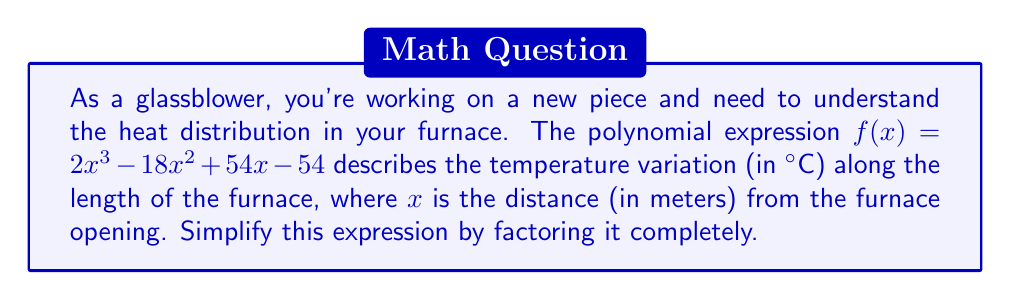Provide a solution to this math problem. Let's approach this step-by-step:

1) First, we can factor out the greatest common factor (GCF):
   $f(x) = 2x^3 - 18x^2 + 54x - 54$
   $f(x) = 2(x^3 - 9x^2 + 27x - 27)$

2) Now, let's focus on the expression inside the parentheses:
   $x^3 - 9x^2 + 27x - 27$

3) This looks like it might be a perfect cube. The general form of a perfect cube is:
   $(a - b)^3 = a^3 - 3a^2b + 3ab^2 - b^3$

4) In our case, if we compare terms:
   $a^3 = x^3$, so $a = x$
   $-b^3 = -27$, so $b = 3$

5) Let's verify if the middle terms match:
   $-3a^2b = -3x^2(3) = -9x^2$ (matches)
   $3ab^2 = 3x(3^2) = 27x$ (matches)

6) Therefore, we can factor the expression inside the parentheses as:
   $x^3 - 9x^2 + 27x - 27 = (x - 3)^3$

7) Putting it all together:
   $f(x) = 2(x^3 - 9x^2 + 27x - 27) = 2(x - 3)^3$

This simplified form tells us that the temperature variation follows a cubic pattern, with a key point at $x = 3$ meters from the furnace opening.
Answer: $f(x) = 2(x - 3)^3$ 